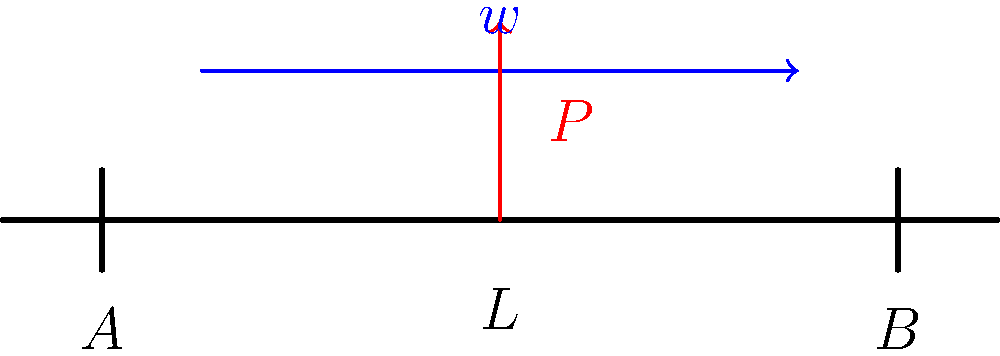In a Football Manager game, you're analyzing the structural integrity of a new stadium. Consider a simply supported beam of length $L$ subjected to a uniformly distributed load $w$ and a point load $P$ at the center. How does the maximum bending moment in this beam compare to a beam with only the uniformly distributed load $w$? Let's approach this step-by-step:

1) For a simply supported beam with only a uniformly distributed load $w$:
   Maximum bending moment: $M_{max1} = \frac{wL^2}{8}$

2) For our beam with both distributed load $w$ and point load $P$:
   a) Moment due to distributed load: $M_w = \frac{wL^2}{8}$
   b) Moment due to point load: $M_P = \frac{PL}{4}$
   c) Total maximum moment: $M_{max2} = M_w + M_P = \frac{wL^2}{8} + \frac{PL}{4}$

3) Comparing the two:
   $M_{max2} = M_{max1} + \frac{PL}{4}$

4) Therefore, the maximum bending moment in the beam with both loads is greater than the beam with only the distributed load by $\frac{PL}{4}$.

5) This additional moment causes increased stress in the beam, which is crucial for structural integrity in stadium design.
Answer: $\frac{PL}{4}$ greater 